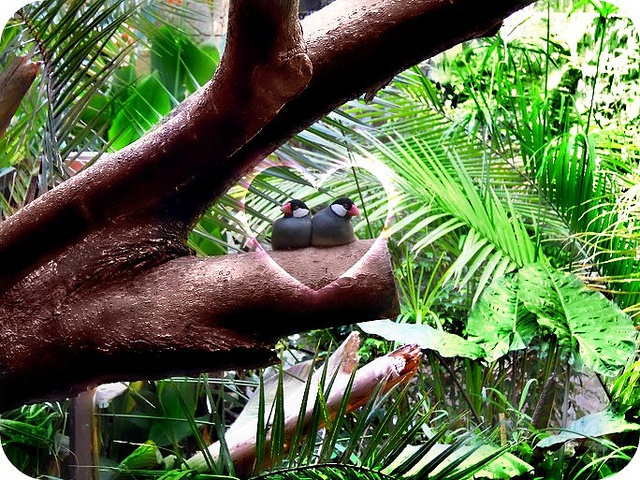Describe the objects in this image and their specific colors. I can see bird in white, black, gray, and maroon tones and bird in white, black, and gray tones in this image. 